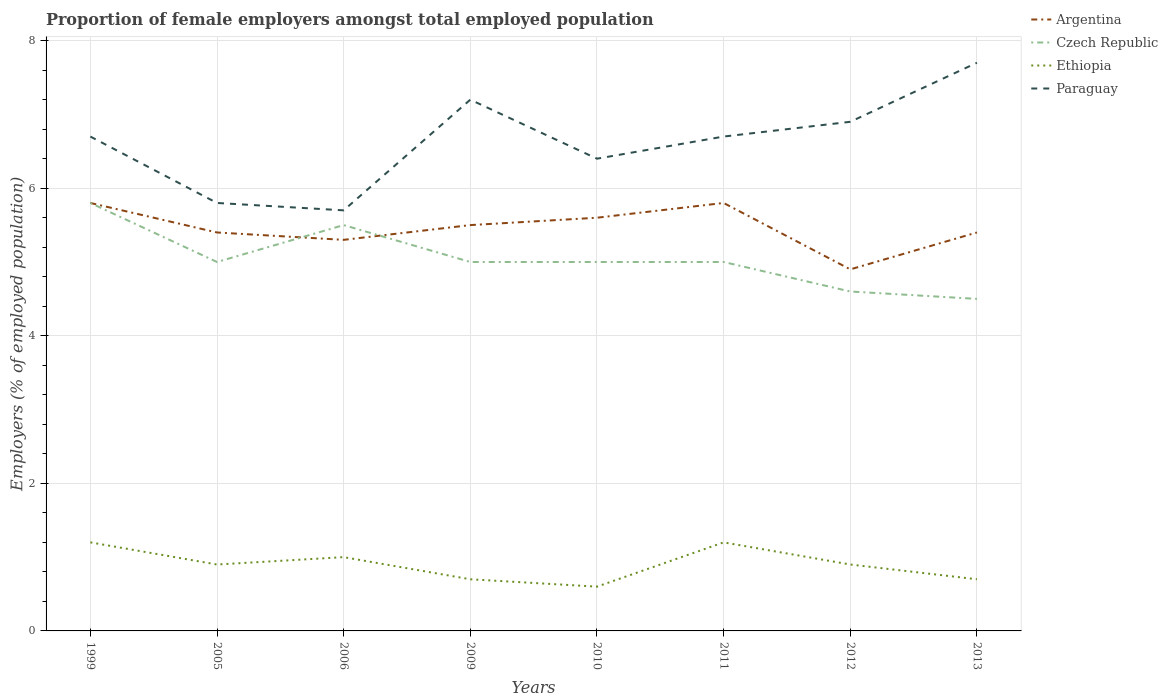Does the line corresponding to Argentina intersect with the line corresponding to Ethiopia?
Provide a short and direct response. No. Is the number of lines equal to the number of legend labels?
Provide a succinct answer. Yes. What is the difference between the highest and the second highest proportion of female employers in Argentina?
Offer a terse response. 0.9. What is the difference between the highest and the lowest proportion of female employers in Ethiopia?
Offer a terse response. 3. Is the proportion of female employers in Ethiopia strictly greater than the proportion of female employers in Czech Republic over the years?
Make the answer very short. Yes. How many lines are there?
Your response must be concise. 4. Are the values on the major ticks of Y-axis written in scientific E-notation?
Your answer should be very brief. No. Does the graph contain grids?
Offer a terse response. Yes. Where does the legend appear in the graph?
Ensure brevity in your answer.  Top right. What is the title of the graph?
Your response must be concise. Proportion of female employers amongst total employed population. What is the label or title of the Y-axis?
Keep it short and to the point. Employers (% of employed population). What is the Employers (% of employed population) in Argentina in 1999?
Your response must be concise. 5.8. What is the Employers (% of employed population) of Czech Republic in 1999?
Provide a short and direct response. 5.8. What is the Employers (% of employed population) in Ethiopia in 1999?
Provide a short and direct response. 1.2. What is the Employers (% of employed population) of Paraguay in 1999?
Offer a terse response. 6.7. What is the Employers (% of employed population) of Argentina in 2005?
Make the answer very short. 5.4. What is the Employers (% of employed population) of Ethiopia in 2005?
Offer a terse response. 0.9. What is the Employers (% of employed population) of Paraguay in 2005?
Provide a short and direct response. 5.8. What is the Employers (% of employed population) in Argentina in 2006?
Provide a short and direct response. 5.3. What is the Employers (% of employed population) of Ethiopia in 2006?
Make the answer very short. 1. What is the Employers (% of employed population) of Paraguay in 2006?
Make the answer very short. 5.7. What is the Employers (% of employed population) in Czech Republic in 2009?
Your answer should be very brief. 5. What is the Employers (% of employed population) of Ethiopia in 2009?
Provide a succinct answer. 0.7. What is the Employers (% of employed population) in Paraguay in 2009?
Your answer should be very brief. 7.2. What is the Employers (% of employed population) of Argentina in 2010?
Keep it short and to the point. 5.6. What is the Employers (% of employed population) in Ethiopia in 2010?
Provide a short and direct response. 0.6. What is the Employers (% of employed population) of Paraguay in 2010?
Offer a very short reply. 6.4. What is the Employers (% of employed population) of Argentina in 2011?
Offer a very short reply. 5.8. What is the Employers (% of employed population) in Czech Republic in 2011?
Your answer should be very brief. 5. What is the Employers (% of employed population) in Ethiopia in 2011?
Make the answer very short. 1.2. What is the Employers (% of employed population) in Paraguay in 2011?
Your response must be concise. 6.7. What is the Employers (% of employed population) of Argentina in 2012?
Provide a short and direct response. 4.9. What is the Employers (% of employed population) of Czech Republic in 2012?
Give a very brief answer. 4.6. What is the Employers (% of employed population) in Ethiopia in 2012?
Provide a succinct answer. 0.9. What is the Employers (% of employed population) in Paraguay in 2012?
Offer a terse response. 6.9. What is the Employers (% of employed population) in Argentina in 2013?
Make the answer very short. 5.4. What is the Employers (% of employed population) of Czech Republic in 2013?
Ensure brevity in your answer.  4.5. What is the Employers (% of employed population) of Ethiopia in 2013?
Keep it short and to the point. 0.7. What is the Employers (% of employed population) of Paraguay in 2013?
Your response must be concise. 7.7. Across all years, what is the maximum Employers (% of employed population) in Argentina?
Your answer should be very brief. 5.8. Across all years, what is the maximum Employers (% of employed population) of Czech Republic?
Provide a succinct answer. 5.8. Across all years, what is the maximum Employers (% of employed population) of Ethiopia?
Make the answer very short. 1.2. Across all years, what is the maximum Employers (% of employed population) in Paraguay?
Keep it short and to the point. 7.7. Across all years, what is the minimum Employers (% of employed population) of Argentina?
Your answer should be compact. 4.9. Across all years, what is the minimum Employers (% of employed population) in Ethiopia?
Make the answer very short. 0.6. Across all years, what is the minimum Employers (% of employed population) of Paraguay?
Offer a very short reply. 5.7. What is the total Employers (% of employed population) of Argentina in the graph?
Offer a very short reply. 43.7. What is the total Employers (% of employed population) of Czech Republic in the graph?
Ensure brevity in your answer.  40.4. What is the total Employers (% of employed population) in Paraguay in the graph?
Offer a very short reply. 53.1. What is the difference between the Employers (% of employed population) in Argentina in 1999 and that in 2005?
Your answer should be compact. 0.4. What is the difference between the Employers (% of employed population) in Ethiopia in 1999 and that in 2005?
Give a very brief answer. 0.3. What is the difference between the Employers (% of employed population) of Paraguay in 1999 and that in 2005?
Give a very brief answer. 0.9. What is the difference between the Employers (% of employed population) of Czech Republic in 1999 and that in 2006?
Offer a very short reply. 0.3. What is the difference between the Employers (% of employed population) in Ethiopia in 1999 and that in 2009?
Keep it short and to the point. 0.5. What is the difference between the Employers (% of employed population) of Czech Republic in 1999 and that in 2010?
Ensure brevity in your answer.  0.8. What is the difference between the Employers (% of employed population) of Paraguay in 1999 and that in 2010?
Your answer should be compact. 0.3. What is the difference between the Employers (% of employed population) in Ethiopia in 1999 and that in 2011?
Provide a short and direct response. 0. What is the difference between the Employers (% of employed population) in Paraguay in 1999 and that in 2011?
Keep it short and to the point. 0. What is the difference between the Employers (% of employed population) in Czech Republic in 1999 and that in 2012?
Provide a short and direct response. 1.2. What is the difference between the Employers (% of employed population) in Paraguay in 1999 and that in 2012?
Your answer should be compact. -0.2. What is the difference between the Employers (% of employed population) in Argentina in 1999 and that in 2013?
Your response must be concise. 0.4. What is the difference between the Employers (% of employed population) in Ethiopia in 1999 and that in 2013?
Provide a succinct answer. 0.5. What is the difference between the Employers (% of employed population) in Argentina in 2005 and that in 2006?
Your answer should be compact. 0.1. What is the difference between the Employers (% of employed population) in Czech Republic in 2005 and that in 2006?
Your response must be concise. -0.5. What is the difference between the Employers (% of employed population) of Ethiopia in 2005 and that in 2006?
Keep it short and to the point. -0.1. What is the difference between the Employers (% of employed population) in Paraguay in 2005 and that in 2006?
Your answer should be compact. 0.1. What is the difference between the Employers (% of employed population) in Czech Republic in 2005 and that in 2009?
Provide a short and direct response. 0. What is the difference between the Employers (% of employed population) of Argentina in 2005 and that in 2010?
Offer a very short reply. -0.2. What is the difference between the Employers (% of employed population) in Czech Republic in 2005 and that in 2011?
Offer a very short reply. 0. What is the difference between the Employers (% of employed population) of Paraguay in 2005 and that in 2011?
Offer a terse response. -0.9. What is the difference between the Employers (% of employed population) in Ethiopia in 2005 and that in 2012?
Your response must be concise. 0. What is the difference between the Employers (% of employed population) of Argentina in 2005 and that in 2013?
Give a very brief answer. 0. What is the difference between the Employers (% of employed population) in Czech Republic in 2005 and that in 2013?
Keep it short and to the point. 0.5. What is the difference between the Employers (% of employed population) of Ethiopia in 2005 and that in 2013?
Provide a short and direct response. 0.2. What is the difference between the Employers (% of employed population) of Paraguay in 2005 and that in 2013?
Give a very brief answer. -1.9. What is the difference between the Employers (% of employed population) in Argentina in 2006 and that in 2010?
Your response must be concise. -0.3. What is the difference between the Employers (% of employed population) in Czech Republic in 2006 and that in 2010?
Offer a very short reply. 0.5. What is the difference between the Employers (% of employed population) in Ethiopia in 2006 and that in 2010?
Make the answer very short. 0.4. What is the difference between the Employers (% of employed population) in Czech Republic in 2006 and that in 2011?
Provide a succinct answer. 0.5. What is the difference between the Employers (% of employed population) in Ethiopia in 2006 and that in 2011?
Give a very brief answer. -0.2. What is the difference between the Employers (% of employed population) of Argentina in 2006 and that in 2012?
Give a very brief answer. 0.4. What is the difference between the Employers (% of employed population) of Argentina in 2006 and that in 2013?
Your answer should be compact. -0.1. What is the difference between the Employers (% of employed population) in Czech Republic in 2006 and that in 2013?
Offer a terse response. 1. What is the difference between the Employers (% of employed population) of Ethiopia in 2006 and that in 2013?
Your response must be concise. 0.3. What is the difference between the Employers (% of employed population) in Paraguay in 2006 and that in 2013?
Your answer should be very brief. -2. What is the difference between the Employers (% of employed population) in Paraguay in 2009 and that in 2010?
Ensure brevity in your answer.  0.8. What is the difference between the Employers (% of employed population) of Argentina in 2009 and that in 2011?
Provide a succinct answer. -0.3. What is the difference between the Employers (% of employed population) of Czech Republic in 2009 and that in 2011?
Ensure brevity in your answer.  0. What is the difference between the Employers (% of employed population) of Czech Republic in 2009 and that in 2012?
Your answer should be compact. 0.4. What is the difference between the Employers (% of employed population) in Czech Republic in 2009 and that in 2013?
Your answer should be compact. 0.5. What is the difference between the Employers (% of employed population) in Ethiopia in 2009 and that in 2013?
Offer a terse response. 0. What is the difference between the Employers (% of employed population) in Paraguay in 2009 and that in 2013?
Make the answer very short. -0.5. What is the difference between the Employers (% of employed population) of Argentina in 2010 and that in 2011?
Ensure brevity in your answer.  -0.2. What is the difference between the Employers (% of employed population) of Czech Republic in 2010 and that in 2011?
Keep it short and to the point. 0. What is the difference between the Employers (% of employed population) in Paraguay in 2010 and that in 2011?
Make the answer very short. -0.3. What is the difference between the Employers (% of employed population) of Argentina in 2010 and that in 2012?
Ensure brevity in your answer.  0.7. What is the difference between the Employers (% of employed population) in Ethiopia in 2010 and that in 2012?
Make the answer very short. -0.3. What is the difference between the Employers (% of employed population) in Argentina in 2010 and that in 2013?
Make the answer very short. 0.2. What is the difference between the Employers (% of employed population) of Paraguay in 2011 and that in 2012?
Your response must be concise. -0.2. What is the difference between the Employers (% of employed population) of Czech Republic in 2011 and that in 2013?
Offer a terse response. 0.5. What is the difference between the Employers (% of employed population) of Paraguay in 2011 and that in 2013?
Provide a short and direct response. -1. What is the difference between the Employers (% of employed population) in Argentina in 1999 and the Employers (% of employed population) in Ethiopia in 2005?
Your answer should be compact. 4.9. What is the difference between the Employers (% of employed population) of Czech Republic in 1999 and the Employers (% of employed population) of Ethiopia in 2005?
Keep it short and to the point. 4.9. What is the difference between the Employers (% of employed population) of Czech Republic in 1999 and the Employers (% of employed population) of Paraguay in 2005?
Give a very brief answer. 0. What is the difference between the Employers (% of employed population) in Argentina in 1999 and the Employers (% of employed population) in Czech Republic in 2006?
Your answer should be very brief. 0.3. What is the difference between the Employers (% of employed population) of Czech Republic in 1999 and the Employers (% of employed population) of Ethiopia in 2006?
Offer a terse response. 4.8. What is the difference between the Employers (% of employed population) of Czech Republic in 1999 and the Employers (% of employed population) of Paraguay in 2006?
Your answer should be compact. 0.1. What is the difference between the Employers (% of employed population) of Czech Republic in 1999 and the Employers (% of employed population) of Ethiopia in 2009?
Your answer should be very brief. 5.1. What is the difference between the Employers (% of employed population) in Argentina in 1999 and the Employers (% of employed population) in Czech Republic in 2010?
Provide a succinct answer. 0.8. What is the difference between the Employers (% of employed population) in Argentina in 1999 and the Employers (% of employed population) in Paraguay in 2010?
Ensure brevity in your answer.  -0.6. What is the difference between the Employers (% of employed population) in Czech Republic in 1999 and the Employers (% of employed population) in Ethiopia in 2010?
Make the answer very short. 5.2. What is the difference between the Employers (% of employed population) of Czech Republic in 1999 and the Employers (% of employed population) of Paraguay in 2010?
Your response must be concise. -0.6. What is the difference between the Employers (% of employed population) in Ethiopia in 1999 and the Employers (% of employed population) in Paraguay in 2010?
Keep it short and to the point. -5.2. What is the difference between the Employers (% of employed population) of Argentina in 1999 and the Employers (% of employed population) of Czech Republic in 2011?
Keep it short and to the point. 0.8. What is the difference between the Employers (% of employed population) in Argentina in 1999 and the Employers (% of employed population) in Ethiopia in 2011?
Make the answer very short. 4.6. What is the difference between the Employers (% of employed population) in Czech Republic in 1999 and the Employers (% of employed population) in Ethiopia in 2011?
Give a very brief answer. 4.6. What is the difference between the Employers (% of employed population) in Argentina in 1999 and the Employers (% of employed population) in Czech Republic in 2012?
Keep it short and to the point. 1.2. What is the difference between the Employers (% of employed population) of Argentina in 1999 and the Employers (% of employed population) of Ethiopia in 2012?
Make the answer very short. 4.9. What is the difference between the Employers (% of employed population) in Argentina in 1999 and the Employers (% of employed population) in Paraguay in 2012?
Offer a very short reply. -1.1. What is the difference between the Employers (% of employed population) in Czech Republic in 1999 and the Employers (% of employed population) in Paraguay in 2012?
Make the answer very short. -1.1. What is the difference between the Employers (% of employed population) in Argentina in 1999 and the Employers (% of employed population) in Czech Republic in 2013?
Your response must be concise. 1.3. What is the difference between the Employers (% of employed population) of Argentina in 1999 and the Employers (% of employed population) of Ethiopia in 2013?
Offer a very short reply. 5.1. What is the difference between the Employers (% of employed population) of Argentina in 1999 and the Employers (% of employed population) of Paraguay in 2013?
Your answer should be compact. -1.9. What is the difference between the Employers (% of employed population) in Czech Republic in 1999 and the Employers (% of employed population) in Ethiopia in 2013?
Give a very brief answer. 5.1. What is the difference between the Employers (% of employed population) of Czech Republic in 1999 and the Employers (% of employed population) of Paraguay in 2013?
Your response must be concise. -1.9. What is the difference between the Employers (% of employed population) in Argentina in 2005 and the Employers (% of employed population) in Ethiopia in 2006?
Offer a terse response. 4.4. What is the difference between the Employers (% of employed population) of Argentina in 2005 and the Employers (% of employed population) of Czech Republic in 2009?
Offer a terse response. 0.4. What is the difference between the Employers (% of employed population) in Argentina in 2005 and the Employers (% of employed population) in Ethiopia in 2009?
Ensure brevity in your answer.  4.7. What is the difference between the Employers (% of employed population) of Argentina in 2005 and the Employers (% of employed population) of Paraguay in 2009?
Provide a succinct answer. -1.8. What is the difference between the Employers (% of employed population) in Czech Republic in 2005 and the Employers (% of employed population) in Ethiopia in 2009?
Your response must be concise. 4.3. What is the difference between the Employers (% of employed population) in Argentina in 2005 and the Employers (% of employed population) in Czech Republic in 2010?
Provide a succinct answer. 0.4. What is the difference between the Employers (% of employed population) of Argentina in 2005 and the Employers (% of employed population) of Ethiopia in 2010?
Keep it short and to the point. 4.8. What is the difference between the Employers (% of employed population) in Czech Republic in 2005 and the Employers (% of employed population) in Ethiopia in 2010?
Make the answer very short. 4.4. What is the difference between the Employers (% of employed population) of Czech Republic in 2005 and the Employers (% of employed population) of Paraguay in 2010?
Offer a terse response. -1.4. What is the difference between the Employers (% of employed population) of Ethiopia in 2005 and the Employers (% of employed population) of Paraguay in 2010?
Provide a short and direct response. -5.5. What is the difference between the Employers (% of employed population) of Argentina in 2005 and the Employers (% of employed population) of Czech Republic in 2011?
Ensure brevity in your answer.  0.4. What is the difference between the Employers (% of employed population) in Czech Republic in 2005 and the Employers (% of employed population) in Paraguay in 2011?
Offer a very short reply. -1.7. What is the difference between the Employers (% of employed population) in Ethiopia in 2005 and the Employers (% of employed population) in Paraguay in 2011?
Give a very brief answer. -5.8. What is the difference between the Employers (% of employed population) of Argentina in 2005 and the Employers (% of employed population) of Czech Republic in 2012?
Make the answer very short. 0.8. What is the difference between the Employers (% of employed population) in Czech Republic in 2005 and the Employers (% of employed population) in Ethiopia in 2012?
Keep it short and to the point. 4.1. What is the difference between the Employers (% of employed population) in Argentina in 2005 and the Employers (% of employed population) in Czech Republic in 2013?
Provide a short and direct response. 0.9. What is the difference between the Employers (% of employed population) of Argentina in 2005 and the Employers (% of employed population) of Ethiopia in 2013?
Keep it short and to the point. 4.7. What is the difference between the Employers (% of employed population) of Czech Republic in 2005 and the Employers (% of employed population) of Paraguay in 2013?
Your answer should be very brief. -2.7. What is the difference between the Employers (% of employed population) of Argentina in 2006 and the Employers (% of employed population) of Ethiopia in 2009?
Offer a very short reply. 4.6. What is the difference between the Employers (% of employed population) in Argentina in 2006 and the Employers (% of employed population) in Paraguay in 2009?
Give a very brief answer. -1.9. What is the difference between the Employers (% of employed population) in Ethiopia in 2006 and the Employers (% of employed population) in Paraguay in 2009?
Give a very brief answer. -6.2. What is the difference between the Employers (% of employed population) of Argentina in 2006 and the Employers (% of employed population) of Ethiopia in 2010?
Offer a very short reply. 4.7. What is the difference between the Employers (% of employed population) of Czech Republic in 2006 and the Employers (% of employed population) of Ethiopia in 2010?
Your answer should be very brief. 4.9. What is the difference between the Employers (% of employed population) of Czech Republic in 2006 and the Employers (% of employed population) of Paraguay in 2010?
Provide a short and direct response. -0.9. What is the difference between the Employers (% of employed population) in Argentina in 2006 and the Employers (% of employed population) in Ethiopia in 2011?
Give a very brief answer. 4.1. What is the difference between the Employers (% of employed population) of Czech Republic in 2006 and the Employers (% of employed population) of Ethiopia in 2011?
Provide a short and direct response. 4.3. What is the difference between the Employers (% of employed population) in Ethiopia in 2006 and the Employers (% of employed population) in Paraguay in 2011?
Make the answer very short. -5.7. What is the difference between the Employers (% of employed population) of Argentina in 2006 and the Employers (% of employed population) of Paraguay in 2012?
Make the answer very short. -1.6. What is the difference between the Employers (% of employed population) in Ethiopia in 2006 and the Employers (% of employed population) in Paraguay in 2012?
Give a very brief answer. -5.9. What is the difference between the Employers (% of employed population) in Argentina in 2006 and the Employers (% of employed population) in Czech Republic in 2013?
Your response must be concise. 0.8. What is the difference between the Employers (% of employed population) of Czech Republic in 2006 and the Employers (% of employed population) of Paraguay in 2013?
Provide a succinct answer. -2.2. What is the difference between the Employers (% of employed population) of Argentina in 2009 and the Employers (% of employed population) of Ethiopia in 2010?
Offer a very short reply. 4.9. What is the difference between the Employers (% of employed population) in Argentina in 2009 and the Employers (% of employed population) in Paraguay in 2010?
Make the answer very short. -0.9. What is the difference between the Employers (% of employed population) of Ethiopia in 2009 and the Employers (% of employed population) of Paraguay in 2010?
Provide a short and direct response. -5.7. What is the difference between the Employers (% of employed population) of Argentina in 2009 and the Employers (% of employed population) of Czech Republic in 2011?
Your answer should be very brief. 0.5. What is the difference between the Employers (% of employed population) in Argentina in 2009 and the Employers (% of employed population) in Ethiopia in 2011?
Make the answer very short. 4.3. What is the difference between the Employers (% of employed population) of Argentina in 2009 and the Employers (% of employed population) of Paraguay in 2011?
Your answer should be very brief. -1.2. What is the difference between the Employers (% of employed population) of Czech Republic in 2009 and the Employers (% of employed population) of Paraguay in 2012?
Provide a short and direct response. -1.9. What is the difference between the Employers (% of employed population) of Argentina in 2009 and the Employers (% of employed population) of Paraguay in 2013?
Offer a terse response. -2.2. What is the difference between the Employers (% of employed population) of Czech Republic in 2009 and the Employers (% of employed population) of Ethiopia in 2013?
Make the answer very short. 4.3. What is the difference between the Employers (% of employed population) of Argentina in 2010 and the Employers (% of employed population) of Paraguay in 2011?
Your answer should be compact. -1.1. What is the difference between the Employers (% of employed population) of Czech Republic in 2010 and the Employers (% of employed population) of Ethiopia in 2011?
Your answer should be very brief. 3.8. What is the difference between the Employers (% of employed population) in Czech Republic in 2010 and the Employers (% of employed population) in Paraguay in 2011?
Offer a terse response. -1.7. What is the difference between the Employers (% of employed population) in Argentina in 2010 and the Employers (% of employed population) in Ethiopia in 2012?
Your answer should be very brief. 4.7. What is the difference between the Employers (% of employed population) of Ethiopia in 2010 and the Employers (% of employed population) of Paraguay in 2012?
Your response must be concise. -6.3. What is the difference between the Employers (% of employed population) of Argentina in 2010 and the Employers (% of employed population) of Czech Republic in 2013?
Your answer should be compact. 1.1. What is the difference between the Employers (% of employed population) of Argentina in 2010 and the Employers (% of employed population) of Ethiopia in 2013?
Provide a short and direct response. 4.9. What is the difference between the Employers (% of employed population) in Argentina in 2010 and the Employers (% of employed population) in Paraguay in 2013?
Offer a terse response. -2.1. What is the difference between the Employers (% of employed population) of Czech Republic in 2011 and the Employers (% of employed population) of Paraguay in 2012?
Your answer should be compact. -1.9. What is the difference between the Employers (% of employed population) in Ethiopia in 2011 and the Employers (% of employed population) in Paraguay in 2012?
Your answer should be very brief. -5.7. What is the difference between the Employers (% of employed population) of Czech Republic in 2011 and the Employers (% of employed population) of Ethiopia in 2013?
Make the answer very short. 4.3. What is the difference between the Employers (% of employed population) of Czech Republic in 2011 and the Employers (% of employed population) of Paraguay in 2013?
Keep it short and to the point. -2.7. What is the difference between the Employers (% of employed population) of Ethiopia in 2012 and the Employers (% of employed population) of Paraguay in 2013?
Your answer should be very brief. -6.8. What is the average Employers (% of employed population) in Argentina per year?
Provide a succinct answer. 5.46. What is the average Employers (% of employed population) in Czech Republic per year?
Offer a very short reply. 5.05. What is the average Employers (% of employed population) of Paraguay per year?
Offer a terse response. 6.64. In the year 1999, what is the difference between the Employers (% of employed population) in Argentina and Employers (% of employed population) in Czech Republic?
Ensure brevity in your answer.  0. In the year 1999, what is the difference between the Employers (% of employed population) of Argentina and Employers (% of employed population) of Paraguay?
Your response must be concise. -0.9. In the year 1999, what is the difference between the Employers (% of employed population) of Ethiopia and Employers (% of employed population) of Paraguay?
Your answer should be very brief. -5.5. In the year 2005, what is the difference between the Employers (% of employed population) of Czech Republic and Employers (% of employed population) of Ethiopia?
Your answer should be compact. 4.1. In the year 2005, what is the difference between the Employers (% of employed population) in Ethiopia and Employers (% of employed population) in Paraguay?
Ensure brevity in your answer.  -4.9. In the year 2006, what is the difference between the Employers (% of employed population) of Argentina and Employers (% of employed population) of Czech Republic?
Your answer should be compact. -0.2. In the year 2006, what is the difference between the Employers (% of employed population) in Argentina and Employers (% of employed population) in Ethiopia?
Make the answer very short. 4.3. In the year 2006, what is the difference between the Employers (% of employed population) in Czech Republic and Employers (% of employed population) in Ethiopia?
Offer a very short reply. 4.5. In the year 2006, what is the difference between the Employers (% of employed population) of Ethiopia and Employers (% of employed population) of Paraguay?
Keep it short and to the point. -4.7. In the year 2009, what is the difference between the Employers (% of employed population) of Argentina and Employers (% of employed population) of Paraguay?
Offer a terse response. -1.7. In the year 2009, what is the difference between the Employers (% of employed population) of Ethiopia and Employers (% of employed population) of Paraguay?
Ensure brevity in your answer.  -6.5. In the year 2010, what is the difference between the Employers (% of employed population) in Czech Republic and Employers (% of employed population) in Ethiopia?
Make the answer very short. 4.4. In the year 2011, what is the difference between the Employers (% of employed population) in Argentina and Employers (% of employed population) in Czech Republic?
Your answer should be compact. 0.8. In the year 2011, what is the difference between the Employers (% of employed population) of Argentina and Employers (% of employed population) of Ethiopia?
Make the answer very short. 4.6. In the year 2011, what is the difference between the Employers (% of employed population) in Argentina and Employers (% of employed population) in Paraguay?
Provide a short and direct response. -0.9. In the year 2012, what is the difference between the Employers (% of employed population) of Argentina and Employers (% of employed population) of Czech Republic?
Provide a succinct answer. 0.3. In the year 2012, what is the difference between the Employers (% of employed population) of Argentina and Employers (% of employed population) of Ethiopia?
Give a very brief answer. 4. In the year 2012, what is the difference between the Employers (% of employed population) in Czech Republic and Employers (% of employed population) in Paraguay?
Give a very brief answer. -2.3. In the year 2013, what is the difference between the Employers (% of employed population) of Argentina and Employers (% of employed population) of Ethiopia?
Offer a very short reply. 4.7. In the year 2013, what is the difference between the Employers (% of employed population) in Ethiopia and Employers (% of employed population) in Paraguay?
Ensure brevity in your answer.  -7. What is the ratio of the Employers (% of employed population) of Argentina in 1999 to that in 2005?
Provide a short and direct response. 1.07. What is the ratio of the Employers (% of employed population) of Czech Republic in 1999 to that in 2005?
Your answer should be compact. 1.16. What is the ratio of the Employers (% of employed population) of Paraguay in 1999 to that in 2005?
Provide a short and direct response. 1.16. What is the ratio of the Employers (% of employed population) of Argentina in 1999 to that in 2006?
Offer a very short reply. 1.09. What is the ratio of the Employers (% of employed population) of Czech Republic in 1999 to that in 2006?
Offer a terse response. 1.05. What is the ratio of the Employers (% of employed population) of Ethiopia in 1999 to that in 2006?
Ensure brevity in your answer.  1.2. What is the ratio of the Employers (% of employed population) in Paraguay in 1999 to that in 2006?
Keep it short and to the point. 1.18. What is the ratio of the Employers (% of employed population) of Argentina in 1999 to that in 2009?
Your answer should be very brief. 1.05. What is the ratio of the Employers (% of employed population) of Czech Republic in 1999 to that in 2009?
Ensure brevity in your answer.  1.16. What is the ratio of the Employers (% of employed population) of Ethiopia in 1999 to that in 2009?
Offer a very short reply. 1.71. What is the ratio of the Employers (% of employed population) in Paraguay in 1999 to that in 2009?
Your answer should be very brief. 0.93. What is the ratio of the Employers (% of employed population) of Argentina in 1999 to that in 2010?
Offer a very short reply. 1.04. What is the ratio of the Employers (% of employed population) in Czech Republic in 1999 to that in 2010?
Ensure brevity in your answer.  1.16. What is the ratio of the Employers (% of employed population) of Ethiopia in 1999 to that in 2010?
Provide a short and direct response. 2. What is the ratio of the Employers (% of employed population) of Paraguay in 1999 to that in 2010?
Your answer should be very brief. 1.05. What is the ratio of the Employers (% of employed population) of Czech Republic in 1999 to that in 2011?
Your response must be concise. 1.16. What is the ratio of the Employers (% of employed population) in Ethiopia in 1999 to that in 2011?
Offer a terse response. 1. What is the ratio of the Employers (% of employed population) in Paraguay in 1999 to that in 2011?
Offer a very short reply. 1. What is the ratio of the Employers (% of employed population) in Argentina in 1999 to that in 2012?
Keep it short and to the point. 1.18. What is the ratio of the Employers (% of employed population) of Czech Republic in 1999 to that in 2012?
Your answer should be very brief. 1.26. What is the ratio of the Employers (% of employed population) in Ethiopia in 1999 to that in 2012?
Your answer should be very brief. 1.33. What is the ratio of the Employers (% of employed population) in Paraguay in 1999 to that in 2012?
Ensure brevity in your answer.  0.97. What is the ratio of the Employers (% of employed population) of Argentina in 1999 to that in 2013?
Make the answer very short. 1.07. What is the ratio of the Employers (% of employed population) of Czech Republic in 1999 to that in 2013?
Ensure brevity in your answer.  1.29. What is the ratio of the Employers (% of employed population) in Ethiopia in 1999 to that in 2013?
Your response must be concise. 1.71. What is the ratio of the Employers (% of employed population) of Paraguay in 1999 to that in 2013?
Offer a terse response. 0.87. What is the ratio of the Employers (% of employed population) in Argentina in 2005 to that in 2006?
Your answer should be very brief. 1.02. What is the ratio of the Employers (% of employed population) of Czech Republic in 2005 to that in 2006?
Provide a succinct answer. 0.91. What is the ratio of the Employers (% of employed population) of Ethiopia in 2005 to that in 2006?
Keep it short and to the point. 0.9. What is the ratio of the Employers (% of employed population) of Paraguay in 2005 to that in 2006?
Your answer should be compact. 1.02. What is the ratio of the Employers (% of employed population) in Argentina in 2005 to that in 2009?
Keep it short and to the point. 0.98. What is the ratio of the Employers (% of employed population) of Czech Republic in 2005 to that in 2009?
Your answer should be very brief. 1. What is the ratio of the Employers (% of employed population) of Ethiopia in 2005 to that in 2009?
Your answer should be compact. 1.29. What is the ratio of the Employers (% of employed population) in Paraguay in 2005 to that in 2009?
Offer a terse response. 0.81. What is the ratio of the Employers (% of employed population) of Argentina in 2005 to that in 2010?
Make the answer very short. 0.96. What is the ratio of the Employers (% of employed population) of Paraguay in 2005 to that in 2010?
Offer a very short reply. 0.91. What is the ratio of the Employers (% of employed population) of Ethiopia in 2005 to that in 2011?
Provide a succinct answer. 0.75. What is the ratio of the Employers (% of employed population) of Paraguay in 2005 to that in 2011?
Your response must be concise. 0.87. What is the ratio of the Employers (% of employed population) in Argentina in 2005 to that in 2012?
Provide a short and direct response. 1.1. What is the ratio of the Employers (% of employed population) of Czech Republic in 2005 to that in 2012?
Ensure brevity in your answer.  1.09. What is the ratio of the Employers (% of employed population) in Ethiopia in 2005 to that in 2012?
Your response must be concise. 1. What is the ratio of the Employers (% of employed population) in Paraguay in 2005 to that in 2012?
Your answer should be compact. 0.84. What is the ratio of the Employers (% of employed population) in Ethiopia in 2005 to that in 2013?
Offer a terse response. 1.29. What is the ratio of the Employers (% of employed population) of Paraguay in 2005 to that in 2013?
Provide a succinct answer. 0.75. What is the ratio of the Employers (% of employed population) in Argentina in 2006 to that in 2009?
Your answer should be compact. 0.96. What is the ratio of the Employers (% of employed population) of Ethiopia in 2006 to that in 2009?
Provide a short and direct response. 1.43. What is the ratio of the Employers (% of employed population) in Paraguay in 2006 to that in 2009?
Keep it short and to the point. 0.79. What is the ratio of the Employers (% of employed population) in Argentina in 2006 to that in 2010?
Your answer should be compact. 0.95. What is the ratio of the Employers (% of employed population) in Paraguay in 2006 to that in 2010?
Ensure brevity in your answer.  0.89. What is the ratio of the Employers (% of employed population) of Argentina in 2006 to that in 2011?
Your answer should be very brief. 0.91. What is the ratio of the Employers (% of employed population) in Paraguay in 2006 to that in 2011?
Provide a succinct answer. 0.85. What is the ratio of the Employers (% of employed population) in Argentina in 2006 to that in 2012?
Your answer should be compact. 1.08. What is the ratio of the Employers (% of employed population) in Czech Republic in 2006 to that in 2012?
Keep it short and to the point. 1.2. What is the ratio of the Employers (% of employed population) of Ethiopia in 2006 to that in 2012?
Offer a very short reply. 1.11. What is the ratio of the Employers (% of employed population) in Paraguay in 2006 to that in 2012?
Offer a very short reply. 0.83. What is the ratio of the Employers (% of employed population) of Argentina in 2006 to that in 2013?
Keep it short and to the point. 0.98. What is the ratio of the Employers (% of employed population) in Czech Republic in 2006 to that in 2013?
Make the answer very short. 1.22. What is the ratio of the Employers (% of employed population) of Ethiopia in 2006 to that in 2013?
Offer a very short reply. 1.43. What is the ratio of the Employers (% of employed population) of Paraguay in 2006 to that in 2013?
Provide a short and direct response. 0.74. What is the ratio of the Employers (% of employed population) in Argentina in 2009 to that in 2010?
Your answer should be compact. 0.98. What is the ratio of the Employers (% of employed population) of Czech Republic in 2009 to that in 2010?
Offer a terse response. 1. What is the ratio of the Employers (% of employed population) in Ethiopia in 2009 to that in 2010?
Give a very brief answer. 1.17. What is the ratio of the Employers (% of employed population) of Argentina in 2009 to that in 2011?
Offer a very short reply. 0.95. What is the ratio of the Employers (% of employed population) in Ethiopia in 2009 to that in 2011?
Provide a succinct answer. 0.58. What is the ratio of the Employers (% of employed population) of Paraguay in 2009 to that in 2011?
Offer a terse response. 1.07. What is the ratio of the Employers (% of employed population) in Argentina in 2009 to that in 2012?
Make the answer very short. 1.12. What is the ratio of the Employers (% of employed population) in Czech Republic in 2009 to that in 2012?
Offer a very short reply. 1.09. What is the ratio of the Employers (% of employed population) in Paraguay in 2009 to that in 2012?
Your answer should be compact. 1.04. What is the ratio of the Employers (% of employed population) in Argentina in 2009 to that in 2013?
Ensure brevity in your answer.  1.02. What is the ratio of the Employers (% of employed population) of Czech Republic in 2009 to that in 2013?
Provide a short and direct response. 1.11. What is the ratio of the Employers (% of employed population) in Paraguay in 2009 to that in 2013?
Offer a very short reply. 0.94. What is the ratio of the Employers (% of employed population) of Argentina in 2010 to that in 2011?
Offer a very short reply. 0.97. What is the ratio of the Employers (% of employed population) in Czech Republic in 2010 to that in 2011?
Offer a very short reply. 1. What is the ratio of the Employers (% of employed population) of Paraguay in 2010 to that in 2011?
Ensure brevity in your answer.  0.96. What is the ratio of the Employers (% of employed population) in Czech Republic in 2010 to that in 2012?
Your answer should be compact. 1.09. What is the ratio of the Employers (% of employed population) in Ethiopia in 2010 to that in 2012?
Offer a very short reply. 0.67. What is the ratio of the Employers (% of employed population) of Paraguay in 2010 to that in 2012?
Provide a short and direct response. 0.93. What is the ratio of the Employers (% of employed population) of Argentina in 2010 to that in 2013?
Ensure brevity in your answer.  1.04. What is the ratio of the Employers (% of employed population) of Czech Republic in 2010 to that in 2013?
Your answer should be compact. 1.11. What is the ratio of the Employers (% of employed population) of Ethiopia in 2010 to that in 2013?
Provide a short and direct response. 0.86. What is the ratio of the Employers (% of employed population) in Paraguay in 2010 to that in 2013?
Offer a very short reply. 0.83. What is the ratio of the Employers (% of employed population) of Argentina in 2011 to that in 2012?
Your answer should be compact. 1.18. What is the ratio of the Employers (% of employed population) in Czech Republic in 2011 to that in 2012?
Provide a succinct answer. 1.09. What is the ratio of the Employers (% of employed population) of Paraguay in 2011 to that in 2012?
Your answer should be very brief. 0.97. What is the ratio of the Employers (% of employed population) in Argentina in 2011 to that in 2013?
Your response must be concise. 1.07. What is the ratio of the Employers (% of employed population) in Ethiopia in 2011 to that in 2013?
Your response must be concise. 1.71. What is the ratio of the Employers (% of employed population) of Paraguay in 2011 to that in 2013?
Ensure brevity in your answer.  0.87. What is the ratio of the Employers (% of employed population) in Argentina in 2012 to that in 2013?
Your answer should be compact. 0.91. What is the ratio of the Employers (% of employed population) in Czech Republic in 2012 to that in 2013?
Your response must be concise. 1.02. What is the ratio of the Employers (% of employed population) of Paraguay in 2012 to that in 2013?
Provide a short and direct response. 0.9. What is the difference between the highest and the second highest Employers (% of employed population) of Argentina?
Provide a succinct answer. 0. What is the difference between the highest and the second highest Employers (% of employed population) of Czech Republic?
Give a very brief answer. 0.3. What is the difference between the highest and the second highest Employers (% of employed population) of Ethiopia?
Offer a terse response. 0. What is the difference between the highest and the second highest Employers (% of employed population) in Paraguay?
Give a very brief answer. 0.5. What is the difference between the highest and the lowest Employers (% of employed population) in Ethiopia?
Your response must be concise. 0.6. 